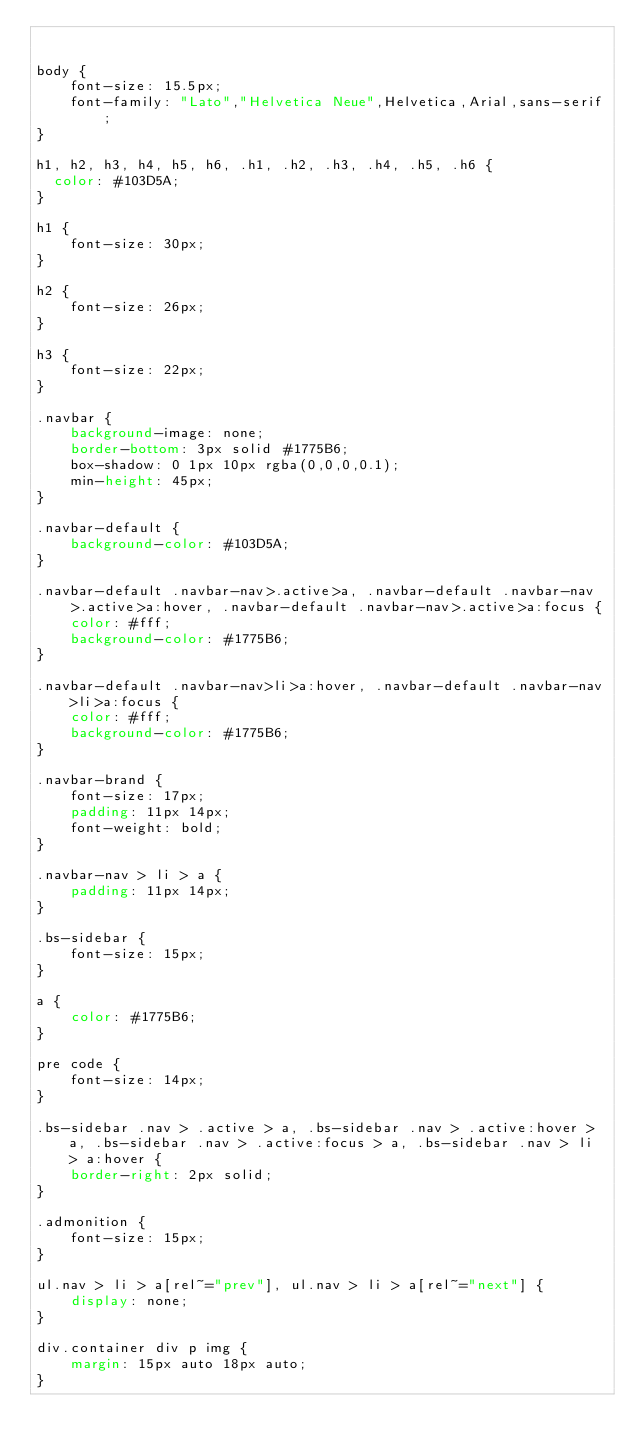<code> <loc_0><loc_0><loc_500><loc_500><_CSS_>

body {
    font-size: 15.5px;
    font-family: "Lato","Helvetica Neue",Helvetica,Arial,sans-serif;
}

h1, h2, h3, h4, h5, h6, .h1, .h2, .h3, .h4, .h5, .h6 {
  color: #103D5A;
}

h1 {
    font-size: 30px;
}

h2 {
    font-size: 26px;
}

h3 {
    font-size: 22px;
}

.navbar {
    background-image: none;
    border-bottom: 3px solid #1775B6;
    box-shadow: 0 1px 10px rgba(0,0,0,0.1);
    min-height: 45px;
}

.navbar-default {
    background-color: #103D5A;
}

.navbar-default .navbar-nav>.active>a, .navbar-default .navbar-nav>.active>a:hover, .navbar-default .navbar-nav>.active>a:focus {
    color: #fff;
    background-color: #1775B6;
}

.navbar-default .navbar-nav>li>a:hover, .navbar-default .navbar-nav>li>a:focus {
    color: #fff;
    background-color: #1775B6;
}

.navbar-brand {
    font-size: 17px;
    padding: 11px 14px;
    font-weight: bold;
}

.navbar-nav > li > a {
    padding: 11px 14px;
}

.bs-sidebar {
    font-size: 15px;
}

a {
    color: #1775B6;
}

pre code {
    font-size: 14px;
}

.bs-sidebar .nav > .active > a, .bs-sidebar .nav > .active:hover > a, .bs-sidebar .nav > .active:focus > a, .bs-sidebar .nav > li > a:hover {
    border-right: 2px solid;
}

.admonition {
    font-size: 15px;
}

ul.nav > li > a[rel~="prev"], ul.nav > li > a[rel~="next"] {
    display: none;
}

div.container div p img {
    margin: 15px auto 18px auto;
}
</code> 